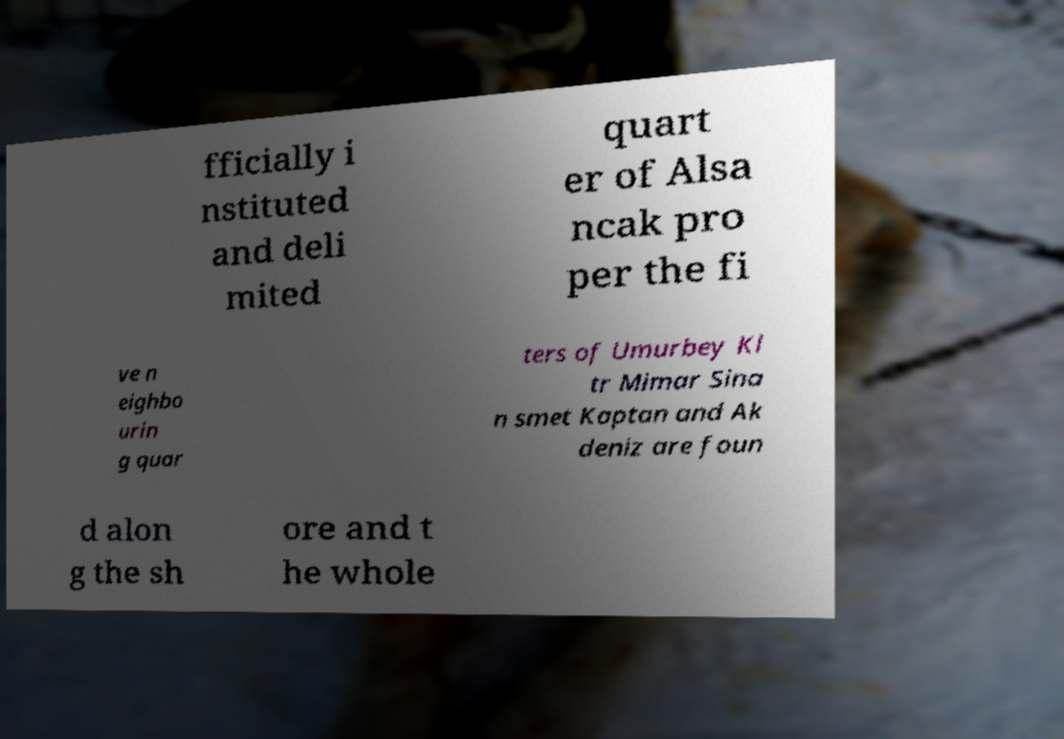Could you extract and type out the text from this image? fficially i nstituted and deli mited quart er of Alsa ncak pro per the fi ve n eighbo urin g quar ters of Umurbey Kl tr Mimar Sina n smet Kaptan and Ak deniz are foun d alon g the sh ore and t he whole 